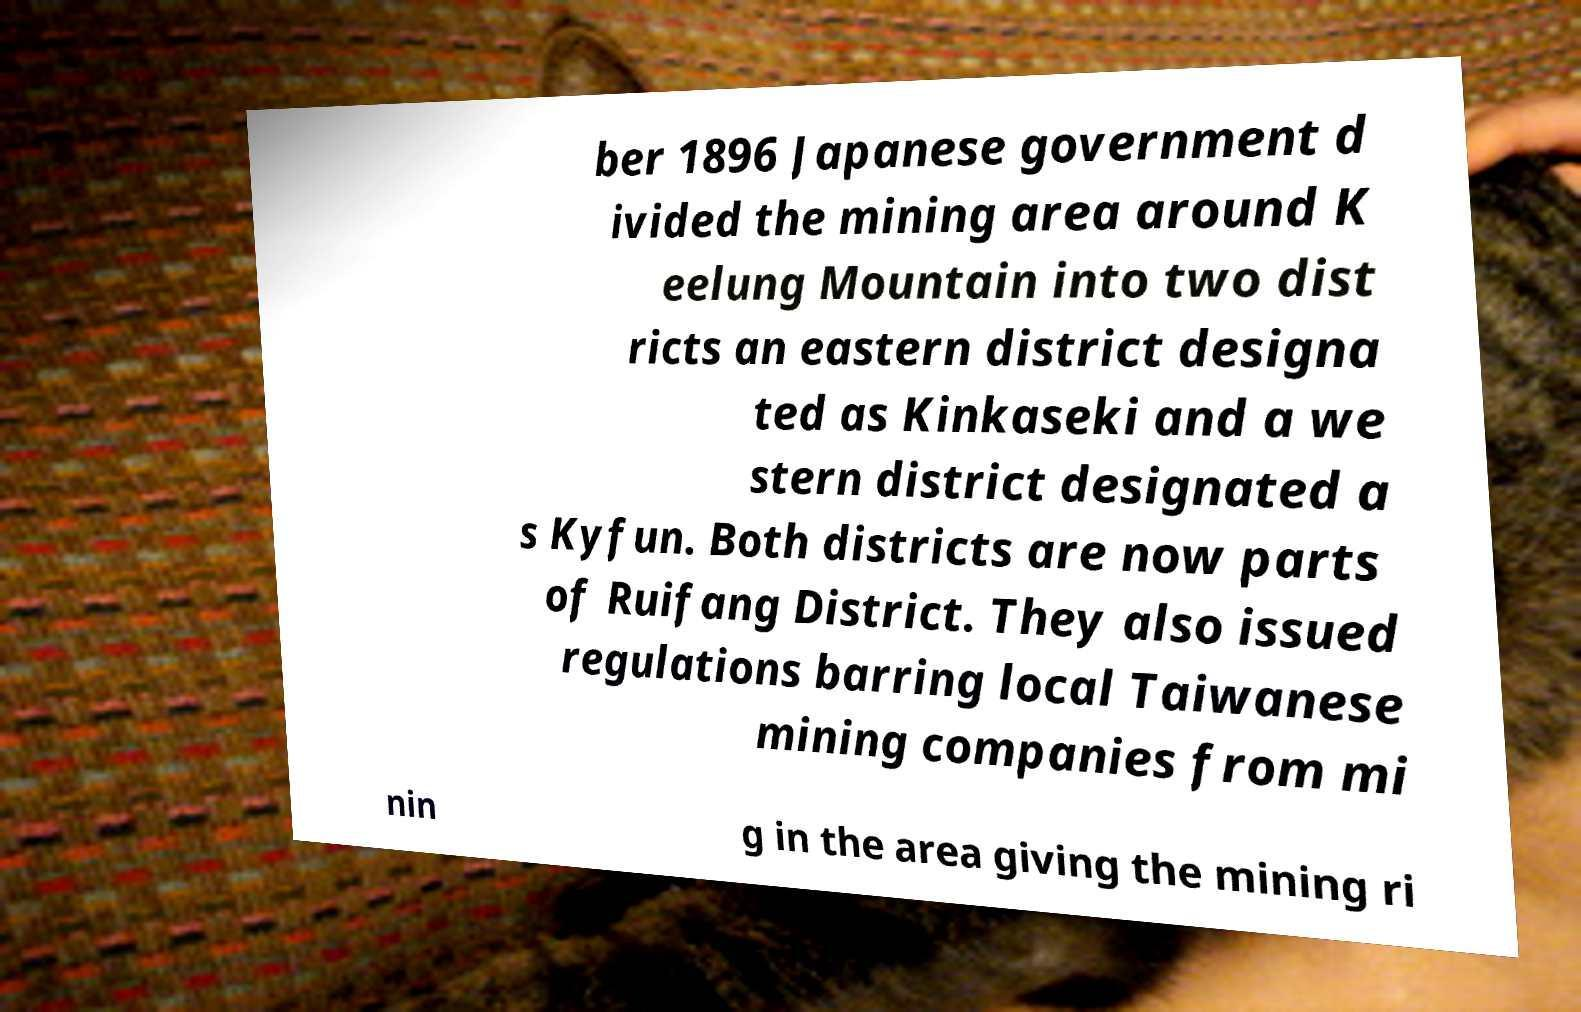Please read and relay the text visible in this image. What does it say? ber 1896 Japanese government d ivided the mining area around K eelung Mountain into two dist ricts an eastern district designa ted as Kinkaseki and a we stern district designated a s Kyfun. Both districts are now parts of Ruifang District. They also issued regulations barring local Taiwanese mining companies from mi nin g in the area giving the mining ri 